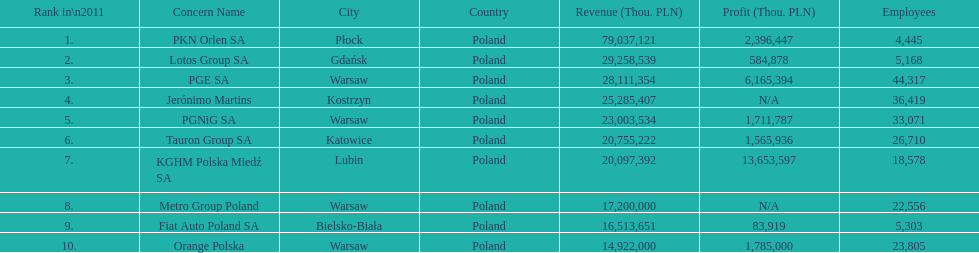What is the number of employees who work for pgnig sa? 33,071. 